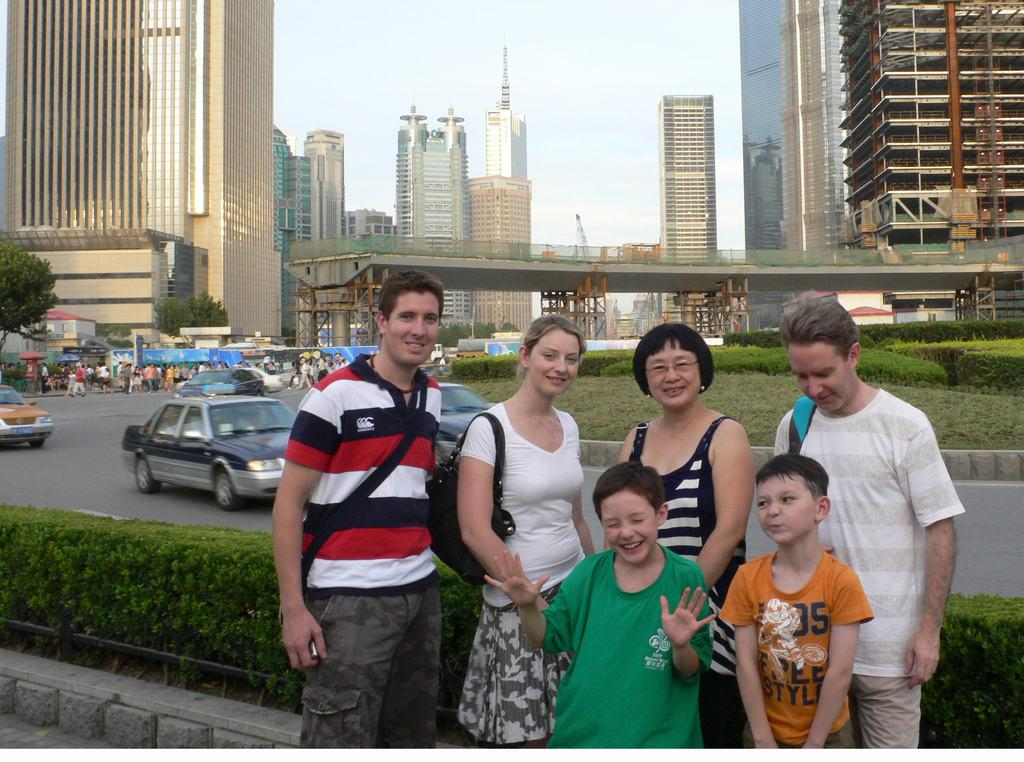What is happening in the center of the image? There are people standing in the center of the image. What can be seen on the road in the image? There are cars on the road. What is visible in the background of the image? Buildings, trees, hedges, people, a bridge, and the sky are visible in the background of the image. What type of cup is being used by the secretary in the image? There is no secretary or cup present in the image. What achievements has the achiever accomplished in the image? There is no achiever or achievements mentioned in the image. 